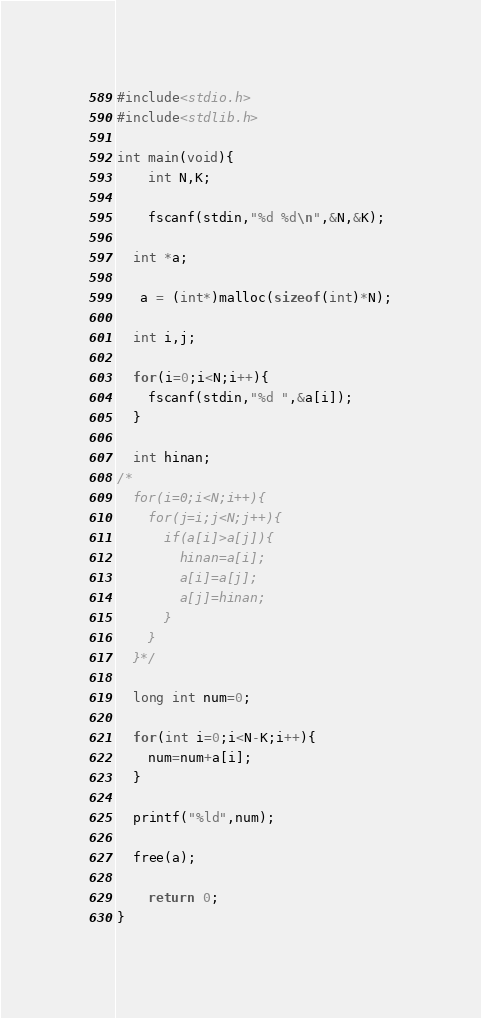Convert code to text. <code><loc_0><loc_0><loc_500><loc_500><_C_>#include<stdio.h>
#include<stdlib.h>

int main(void){
 	int N,K;

	fscanf(stdin,"%d %d\n",&N,&K);
  
  int *a;
  
   a = (int*)malloc(sizeof(int)*N);

  int i,j;

  for(i=0;i<N;i++){
    fscanf(stdin,"%d ",&a[i]);
  }

  int hinan;
/*
  for(i=0;i<N;i++){
    for(j=i;j<N;j++){
      if(a[i]>a[j]){
        hinan=a[i];
        a[i]=a[j];
        a[j]=hinan;
      }
    }
  }*/

  long int num=0;

  for(int i=0;i<N-K;i++){
    num=num+a[i];
  }

  printf("%ld",num);

  free(a);
  
  	return 0;
}</code> 